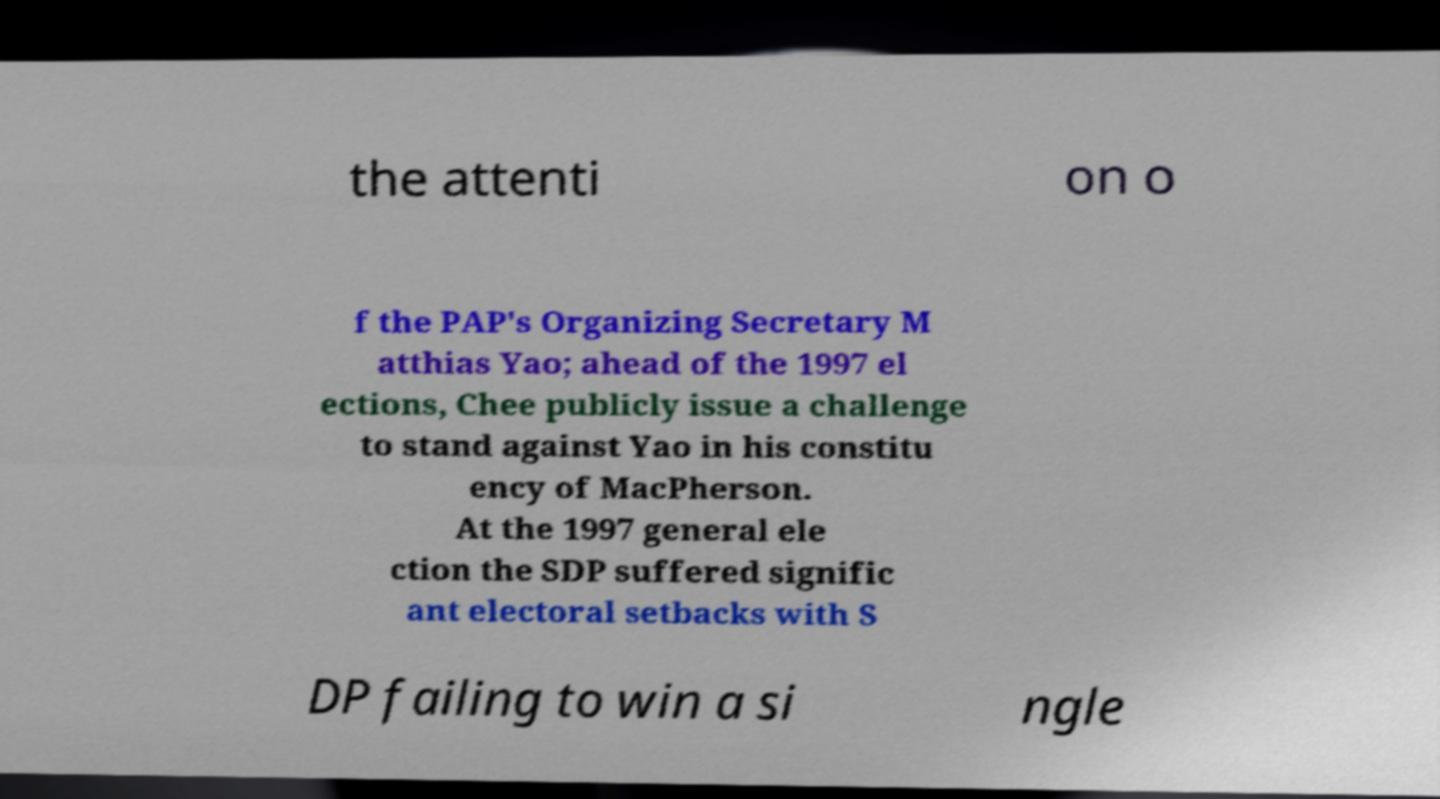For documentation purposes, I need the text within this image transcribed. Could you provide that? the attenti on o f the PAP's Organizing Secretary M atthias Yao; ahead of the 1997 el ections, Chee publicly issue a challenge to stand against Yao in his constitu ency of MacPherson. At the 1997 general ele ction the SDP suffered signific ant electoral setbacks with S DP failing to win a si ngle 